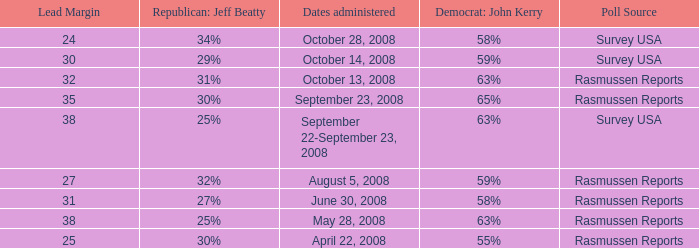What is hte date where republican jeaff beatty is 34%? October 28, 2008. 